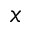Convert formula to latex. <formula><loc_0><loc_0><loc_500><loc_500>x</formula> 